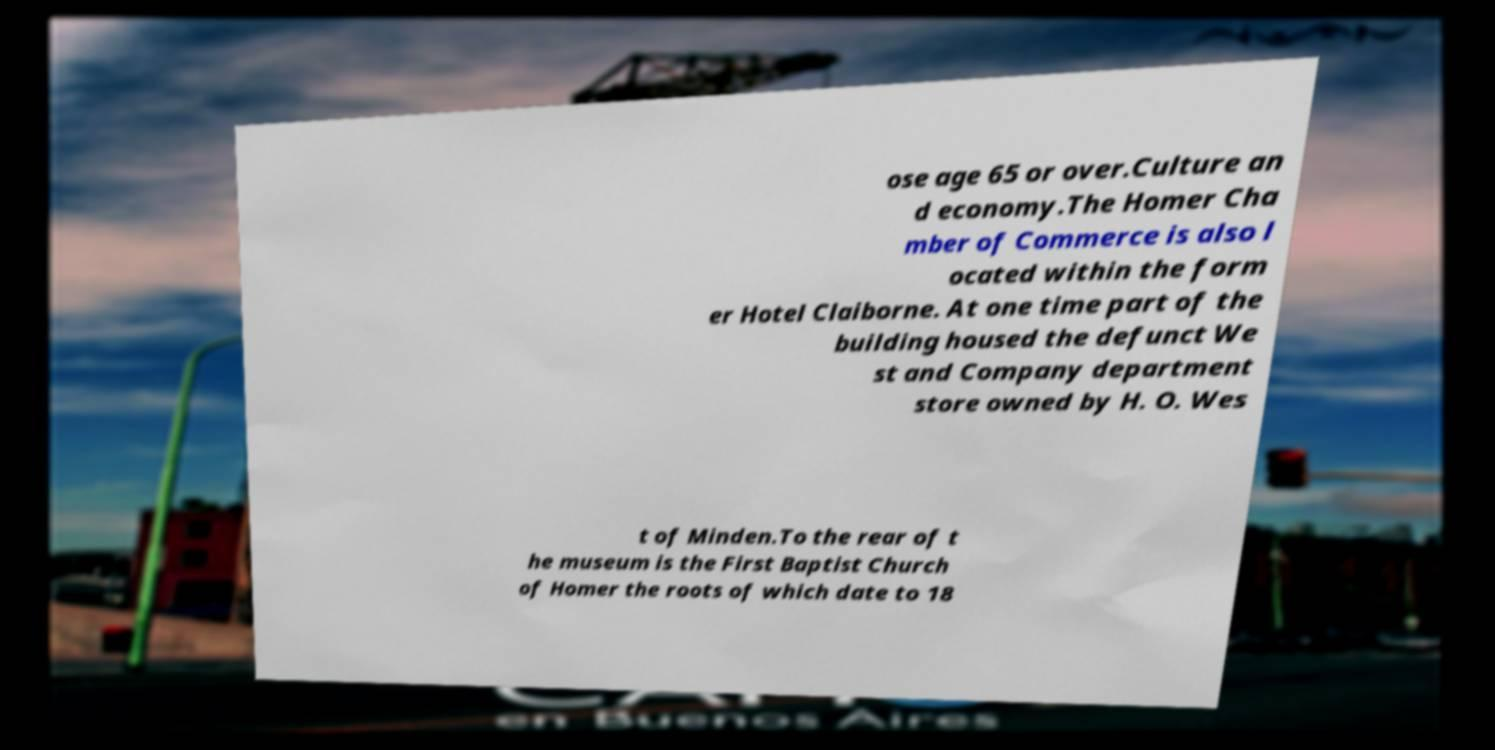Can you accurately transcribe the text from the provided image for me? ose age 65 or over.Culture an d economy.The Homer Cha mber of Commerce is also l ocated within the form er Hotel Claiborne. At one time part of the building housed the defunct We st and Company department store owned by H. O. Wes t of Minden.To the rear of t he museum is the First Baptist Church of Homer the roots of which date to 18 